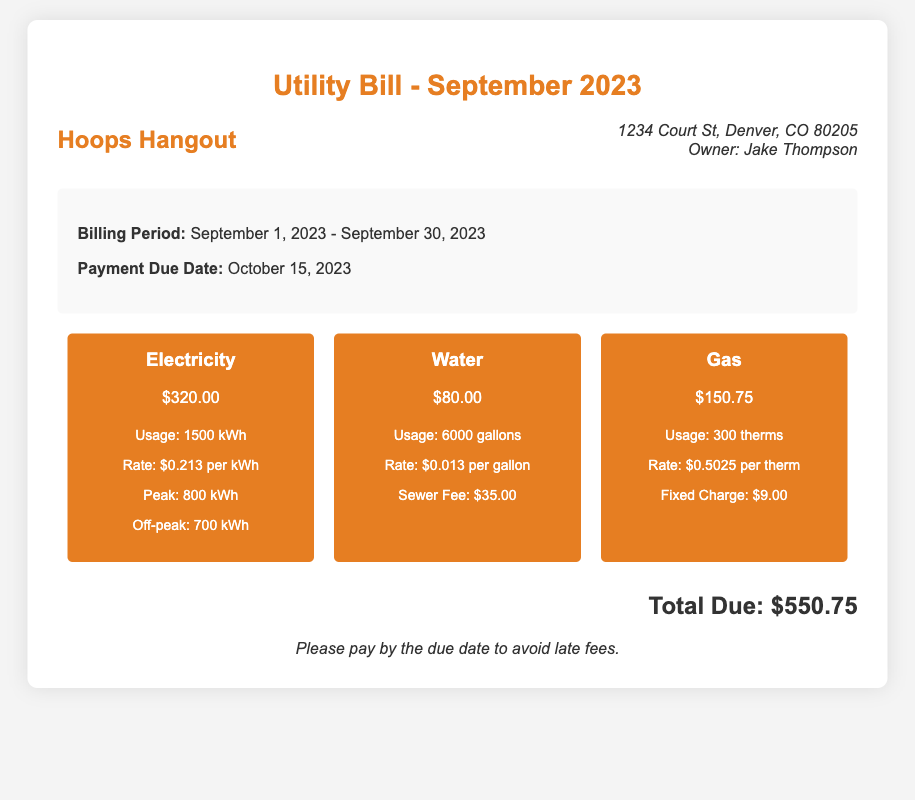What is the billing period for the utility bill? The billing period is indicated in the document as September 1, 2023, to September 30, 2023.
Answer: September 1, 2023 - September 30, 2023 What is the total amount due for the utility bill? The total due is stated clearly in the document as the final amount at the bottom.
Answer: $550.75 How much was charged for electricity? The electricity charge is detailed within the charges section, stating the specific amount.
Answer: $320.00 What is the rate per therm for gas usage? The rate for gas usage is provided in the gas charges details section of the document.
Answer: $0.5025 per therm What is the sewer fee included in the water charges? The sewer fee is mentioned within the water charges section, indicating an additional cost beyond the water usage.
Answer: $35.00 How many gallons of water were used? The water usage is listed in the charges section, providing the specific quantity used.
Answer: 6000 gallons What is the due date for the utility bill payment? The payment due date is specified in the bill information section of the document.
Answer: October 15, 2023 What is the fixed charge included in the gas charges? The fixed charge for gas is detailed in the gas section under its costs.
Answer: $9.00 What was the peak electricity usage in kWh? The peak electricity usage is outlined in the electricity charges details provided in the document.
Answer: 800 kWh 